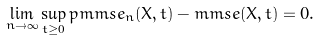Convert formula to latex. <formula><loc_0><loc_0><loc_500><loc_500>\lim _ { n \to \infty } \sup _ { t \geq 0 } p m m s e _ { n } ( X , t ) - m m s e ( X , t ) = 0 .</formula> 